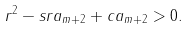<formula> <loc_0><loc_0><loc_500><loc_500>r ^ { 2 } - s r a _ { m + 2 } + c a _ { m + 2 } > 0 .</formula> 